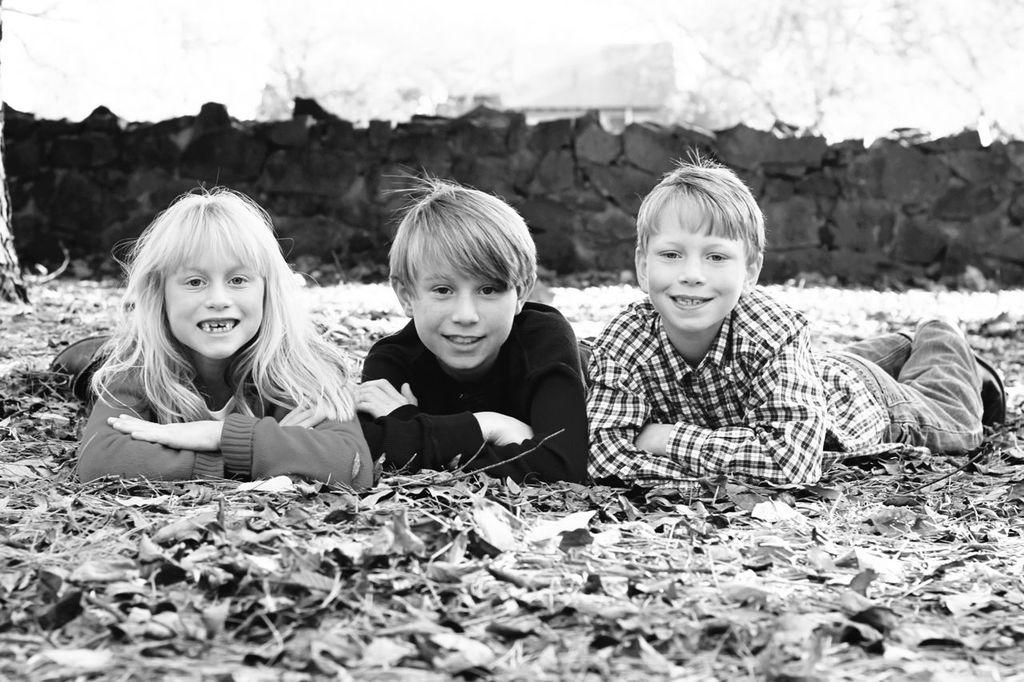Who is present in the image? There are children in the image. What are the children doing in the image? The children are laying on the ground. What can be seen in the background of the image? There is a stone wall visible at the top of the image. What color are the children's eyes in the image? The image does not provide enough detail to determine the color of the children's eyes. What type of bun is being served at the picnic in the image? There is no picnic or bun present in the image. 